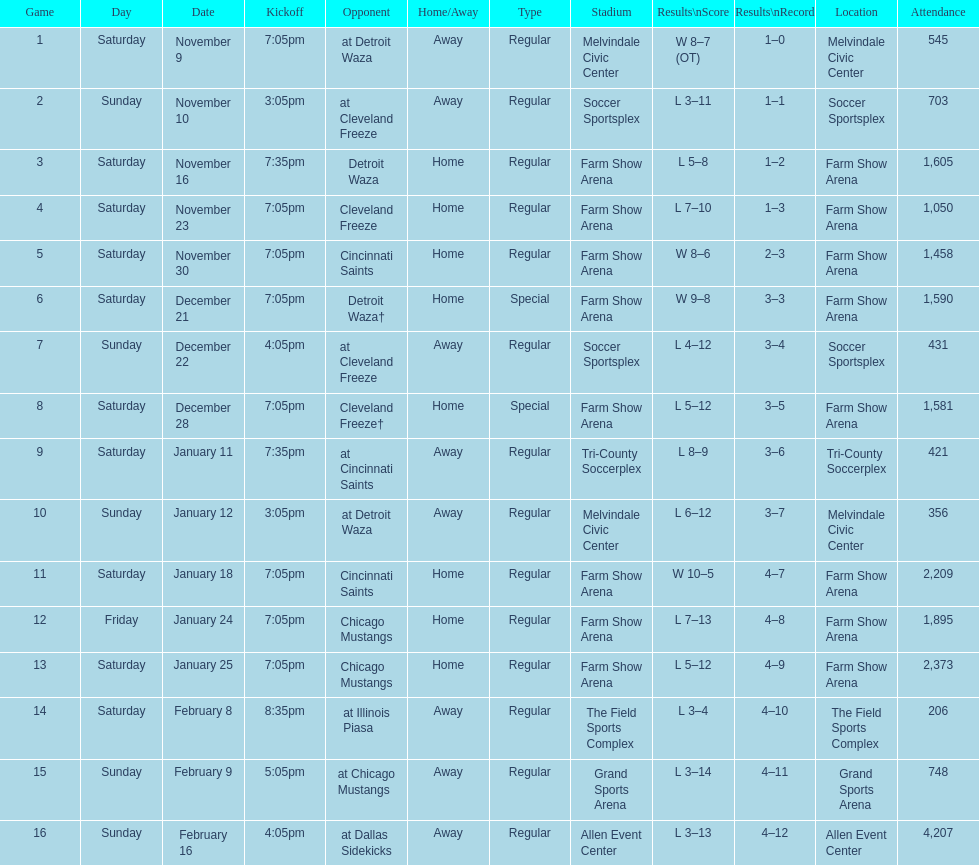Can you parse all the data within this table? {'header': ['Game', 'Day', 'Date', 'Kickoff', 'Opponent', 'Home/Away', 'Type', 'Stadium', 'Results\\nScore', 'Results\\nRecord', 'Location', 'Attendance'], 'rows': [['1', 'Saturday', 'November 9', '7:05pm', 'at Detroit Waza', 'Away', 'Regular', 'Melvindale Civic Center', 'W 8–7 (OT)', '1–0', 'Melvindale Civic Center', '545'], ['2', 'Sunday', 'November 10', '3:05pm', 'at Cleveland Freeze', 'Away', 'Regular', 'Soccer Sportsplex', 'L 3–11', '1–1', 'Soccer Sportsplex', '703'], ['3', 'Saturday', 'November 16', '7:35pm', 'Detroit Waza', 'Home', 'Regular', 'Farm Show Arena', 'L 5–8', '1–2', 'Farm Show Arena', '1,605'], ['4', 'Saturday', 'November 23', '7:05pm', 'Cleveland Freeze', 'Home', 'Regular', 'Farm Show Arena', 'L 7–10', '1–3', 'Farm Show Arena', '1,050'], ['5', 'Saturday', 'November 30', '7:05pm', 'Cincinnati Saints', 'Home', 'Regular', 'Farm Show Arena', 'W 8–6', '2–3', 'Farm Show Arena', '1,458'], ['6', 'Saturday', 'December 21', '7:05pm', 'Detroit Waza†', 'Home', 'Special', 'Farm Show Arena', 'W 9–8', '3–3', 'Farm Show Arena', '1,590'], ['7', 'Sunday', 'December 22', '4:05pm', 'at Cleveland Freeze', 'Away', 'Regular', 'Soccer Sportsplex', 'L 4–12', '3–4', 'Soccer Sportsplex', '431'], ['8', 'Saturday', 'December 28', '7:05pm', 'Cleveland Freeze†', 'Home', 'Special', 'Farm Show Arena', 'L 5–12', '3–5', 'Farm Show Arena', '1,581'], ['9', 'Saturday', 'January 11', '7:35pm', 'at Cincinnati Saints', 'Away', 'Regular', 'Tri-County Soccerplex', 'L 8–9', '3–6', 'Tri-County Soccerplex', '421'], ['10', 'Sunday', 'January 12', '3:05pm', 'at Detroit Waza', 'Away', 'Regular', 'Melvindale Civic Center', 'L 6–12', '3–7', 'Melvindale Civic Center', '356'], ['11', 'Saturday', 'January 18', '7:05pm', 'Cincinnati Saints', 'Home', 'Regular', 'Farm Show Arena', 'W 10–5', '4–7', 'Farm Show Arena', '2,209'], ['12', 'Friday', 'January 24', '7:05pm', 'Chicago Mustangs', 'Home', 'Regular', 'Farm Show Arena', 'L 7–13', '4–8', 'Farm Show Arena', '1,895'], ['13', 'Saturday', 'January 25', '7:05pm', 'Chicago Mustangs', 'Home', 'Regular', 'Farm Show Arena', 'L 5–12', '4–9', 'Farm Show Arena', '2,373'], ['14', 'Saturday', 'February 8', '8:35pm', 'at Illinois Piasa', 'Away', 'Regular', 'The Field Sports Complex', 'L 3–4', '4–10', 'The Field Sports Complex', '206'], ['15', 'Sunday', 'February 9', '5:05pm', 'at Chicago Mustangs', 'Away', 'Regular', 'Grand Sports Arena', 'L 3–14', '4–11', 'Grand Sports Arena', '748'], ['16', 'Sunday', 'February 16', '4:05pm', 'at Dallas Sidekicks', 'Away', 'Regular', 'Allen Event Center', 'L 3–13', '4–12', 'Allen Event Center', '4,207']]} Which opponent is listed after cleveland freeze in the table? Detroit Waza. 